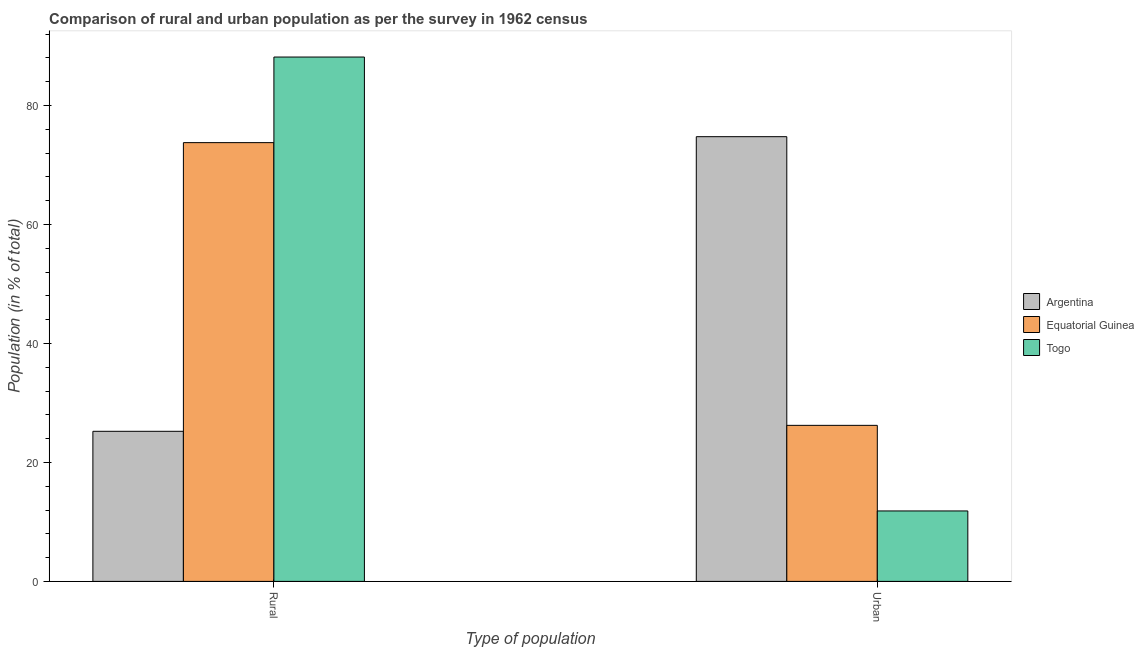Are the number of bars per tick equal to the number of legend labels?
Your answer should be compact. Yes. What is the label of the 2nd group of bars from the left?
Ensure brevity in your answer.  Urban. What is the urban population in Togo?
Give a very brief answer. 11.84. Across all countries, what is the maximum rural population?
Your answer should be compact. 88.16. Across all countries, what is the minimum urban population?
Provide a succinct answer. 11.84. In which country was the rural population minimum?
Ensure brevity in your answer.  Argentina. What is the total rural population in the graph?
Your response must be concise. 187.16. What is the difference between the urban population in Togo and that in Equatorial Guinea?
Give a very brief answer. -14.39. What is the difference between the rural population in Togo and the urban population in Equatorial Guinea?
Offer a very short reply. 61.92. What is the average urban population per country?
Make the answer very short. 37.62. What is the difference between the rural population and urban population in Argentina?
Offer a very short reply. -49.53. In how many countries, is the rural population greater than 52 %?
Provide a short and direct response. 2. What is the ratio of the rural population in Equatorial Guinea to that in Togo?
Give a very brief answer. 0.84. What does the 2nd bar from the left in Rural represents?
Offer a very short reply. Equatorial Guinea. What does the 1st bar from the right in Rural represents?
Give a very brief answer. Togo. How many bars are there?
Give a very brief answer. 6. Are all the bars in the graph horizontal?
Provide a succinct answer. No. How many countries are there in the graph?
Make the answer very short. 3. Are the values on the major ticks of Y-axis written in scientific E-notation?
Provide a succinct answer. No. What is the title of the graph?
Make the answer very short. Comparison of rural and urban population as per the survey in 1962 census. What is the label or title of the X-axis?
Your response must be concise. Type of population. What is the label or title of the Y-axis?
Ensure brevity in your answer.  Population (in % of total). What is the Population (in % of total) of Argentina in Rural?
Provide a short and direct response. 25.23. What is the Population (in % of total) in Equatorial Guinea in Rural?
Provide a short and direct response. 73.77. What is the Population (in % of total) in Togo in Rural?
Give a very brief answer. 88.16. What is the Population (in % of total) of Argentina in Urban?
Your answer should be very brief. 74.77. What is the Population (in % of total) of Equatorial Guinea in Urban?
Give a very brief answer. 26.23. What is the Population (in % of total) in Togo in Urban?
Provide a short and direct response. 11.84. Across all Type of population, what is the maximum Population (in % of total) in Argentina?
Your response must be concise. 74.77. Across all Type of population, what is the maximum Population (in % of total) of Equatorial Guinea?
Your answer should be compact. 73.77. Across all Type of population, what is the maximum Population (in % of total) of Togo?
Provide a short and direct response. 88.16. Across all Type of population, what is the minimum Population (in % of total) of Argentina?
Ensure brevity in your answer.  25.23. Across all Type of population, what is the minimum Population (in % of total) in Equatorial Guinea?
Your answer should be very brief. 26.23. Across all Type of population, what is the minimum Population (in % of total) of Togo?
Offer a terse response. 11.84. What is the difference between the Population (in % of total) of Argentina in Rural and that in Urban?
Your answer should be very brief. -49.53. What is the difference between the Population (in % of total) in Equatorial Guinea in Rural and that in Urban?
Give a very brief answer. 47.53. What is the difference between the Population (in % of total) in Togo in Rural and that in Urban?
Keep it short and to the point. 76.31. What is the difference between the Population (in % of total) in Argentina in Rural and the Population (in % of total) in Equatorial Guinea in Urban?
Keep it short and to the point. -1. What is the difference between the Population (in % of total) of Argentina in Rural and the Population (in % of total) of Togo in Urban?
Offer a very short reply. 13.39. What is the difference between the Population (in % of total) in Equatorial Guinea in Rural and the Population (in % of total) in Togo in Urban?
Provide a short and direct response. 61.92. What is the average Population (in % of total) in Argentina per Type of population?
Make the answer very short. 50. What is the average Population (in % of total) in Equatorial Guinea per Type of population?
Provide a succinct answer. 50. What is the difference between the Population (in % of total) in Argentina and Population (in % of total) in Equatorial Guinea in Rural?
Your answer should be very brief. -48.53. What is the difference between the Population (in % of total) of Argentina and Population (in % of total) of Togo in Rural?
Ensure brevity in your answer.  -62.92. What is the difference between the Population (in % of total) of Equatorial Guinea and Population (in % of total) of Togo in Rural?
Offer a terse response. -14.39. What is the difference between the Population (in % of total) in Argentina and Population (in % of total) in Equatorial Guinea in Urban?
Ensure brevity in your answer.  48.53. What is the difference between the Population (in % of total) of Argentina and Population (in % of total) of Togo in Urban?
Provide a succinct answer. 62.92. What is the difference between the Population (in % of total) in Equatorial Guinea and Population (in % of total) in Togo in Urban?
Give a very brief answer. 14.39. What is the ratio of the Population (in % of total) of Argentina in Rural to that in Urban?
Keep it short and to the point. 0.34. What is the ratio of the Population (in % of total) in Equatorial Guinea in Rural to that in Urban?
Offer a terse response. 2.81. What is the ratio of the Population (in % of total) in Togo in Rural to that in Urban?
Provide a succinct answer. 7.44. What is the difference between the highest and the second highest Population (in % of total) in Argentina?
Provide a short and direct response. 49.53. What is the difference between the highest and the second highest Population (in % of total) in Equatorial Guinea?
Keep it short and to the point. 47.53. What is the difference between the highest and the second highest Population (in % of total) of Togo?
Your response must be concise. 76.31. What is the difference between the highest and the lowest Population (in % of total) of Argentina?
Give a very brief answer. 49.53. What is the difference between the highest and the lowest Population (in % of total) in Equatorial Guinea?
Make the answer very short. 47.53. What is the difference between the highest and the lowest Population (in % of total) of Togo?
Ensure brevity in your answer.  76.31. 